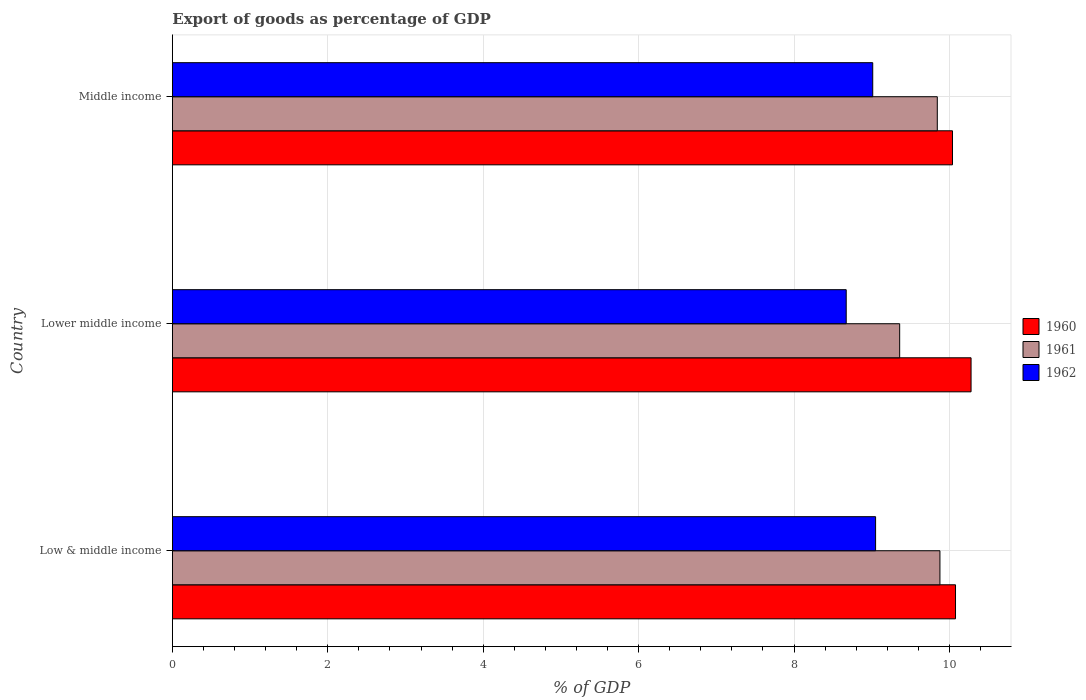How many different coloured bars are there?
Offer a very short reply. 3. How many bars are there on the 3rd tick from the bottom?
Ensure brevity in your answer.  3. What is the label of the 3rd group of bars from the top?
Provide a short and direct response. Low & middle income. In how many cases, is the number of bars for a given country not equal to the number of legend labels?
Your answer should be very brief. 0. What is the export of goods as percentage of GDP in 1960 in Lower middle income?
Your response must be concise. 10.28. Across all countries, what is the maximum export of goods as percentage of GDP in 1960?
Your response must be concise. 10.28. Across all countries, what is the minimum export of goods as percentage of GDP in 1961?
Offer a terse response. 9.36. In which country was the export of goods as percentage of GDP in 1961 maximum?
Your answer should be very brief. Low & middle income. In which country was the export of goods as percentage of GDP in 1961 minimum?
Make the answer very short. Lower middle income. What is the total export of goods as percentage of GDP in 1960 in the graph?
Your response must be concise. 30.4. What is the difference between the export of goods as percentage of GDP in 1960 in Lower middle income and that in Middle income?
Keep it short and to the point. 0.24. What is the difference between the export of goods as percentage of GDP in 1960 in Middle income and the export of goods as percentage of GDP in 1962 in Low & middle income?
Ensure brevity in your answer.  0.99. What is the average export of goods as percentage of GDP in 1961 per country?
Ensure brevity in your answer.  9.69. What is the difference between the export of goods as percentage of GDP in 1961 and export of goods as percentage of GDP in 1960 in Low & middle income?
Your answer should be very brief. -0.2. In how many countries, is the export of goods as percentage of GDP in 1960 greater than 5.2 %?
Provide a short and direct response. 3. What is the ratio of the export of goods as percentage of GDP in 1962 in Low & middle income to that in Lower middle income?
Your answer should be very brief. 1.04. Is the export of goods as percentage of GDP in 1960 in Low & middle income less than that in Middle income?
Provide a short and direct response. No. Is the difference between the export of goods as percentage of GDP in 1961 in Lower middle income and Middle income greater than the difference between the export of goods as percentage of GDP in 1960 in Lower middle income and Middle income?
Offer a very short reply. No. What is the difference between the highest and the second highest export of goods as percentage of GDP in 1961?
Provide a short and direct response. 0.03. What is the difference between the highest and the lowest export of goods as percentage of GDP in 1960?
Make the answer very short. 0.24. In how many countries, is the export of goods as percentage of GDP in 1960 greater than the average export of goods as percentage of GDP in 1960 taken over all countries?
Offer a very short reply. 1. What does the 1st bar from the bottom in Lower middle income represents?
Ensure brevity in your answer.  1960. Is it the case that in every country, the sum of the export of goods as percentage of GDP in 1962 and export of goods as percentage of GDP in 1961 is greater than the export of goods as percentage of GDP in 1960?
Provide a succinct answer. Yes. How many bars are there?
Offer a very short reply. 9. Are all the bars in the graph horizontal?
Your answer should be compact. Yes. Does the graph contain any zero values?
Offer a terse response. No. Where does the legend appear in the graph?
Your answer should be very brief. Center right. What is the title of the graph?
Ensure brevity in your answer.  Export of goods as percentage of GDP. What is the label or title of the X-axis?
Your response must be concise. % of GDP. What is the % of GDP in 1960 in Low & middle income?
Offer a very short reply. 10.08. What is the % of GDP of 1961 in Low & middle income?
Your response must be concise. 9.88. What is the % of GDP in 1962 in Low & middle income?
Offer a terse response. 9.05. What is the % of GDP of 1960 in Lower middle income?
Give a very brief answer. 10.28. What is the % of GDP of 1961 in Lower middle income?
Make the answer very short. 9.36. What is the % of GDP of 1962 in Lower middle income?
Give a very brief answer. 8.67. What is the % of GDP of 1960 in Middle income?
Keep it short and to the point. 10.04. What is the % of GDP in 1961 in Middle income?
Your answer should be very brief. 9.84. What is the % of GDP in 1962 in Middle income?
Make the answer very short. 9.01. Across all countries, what is the maximum % of GDP of 1960?
Keep it short and to the point. 10.28. Across all countries, what is the maximum % of GDP in 1961?
Offer a terse response. 9.88. Across all countries, what is the maximum % of GDP in 1962?
Your answer should be compact. 9.05. Across all countries, what is the minimum % of GDP in 1960?
Give a very brief answer. 10.04. Across all countries, what is the minimum % of GDP of 1961?
Offer a terse response. 9.36. Across all countries, what is the minimum % of GDP in 1962?
Ensure brevity in your answer.  8.67. What is the total % of GDP in 1960 in the graph?
Make the answer very short. 30.4. What is the total % of GDP of 1961 in the graph?
Offer a terse response. 29.08. What is the total % of GDP of 1962 in the graph?
Your answer should be very brief. 26.74. What is the difference between the % of GDP of 1961 in Low & middle income and that in Lower middle income?
Give a very brief answer. 0.52. What is the difference between the % of GDP of 1962 in Low & middle income and that in Lower middle income?
Provide a succinct answer. 0.38. What is the difference between the % of GDP of 1960 in Low & middle income and that in Middle income?
Provide a short and direct response. 0.04. What is the difference between the % of GDP in 1961 in Low & middle income and that in Middle income?
Offer a very short reply. 0.03. What is the difference between the % of GDP in 1962 in Low & middle income and that in Middle income?
Keep it short and to the point. 0.04. What is the difference between the % of GDP in 1960 in Lower middle income and that in Middle income?
Make the answer very short. 0.24. What is the difference between the % of GDP of 1961 in Lower middle income and that in Middle income?
Provide a short and direct response. -0.48. What is the difference between the % of GDP in 1962 in Lower middle income and that in Middle income?
Ensure brevity in your answer.  -0.34. What is the difference between the % of GDP of 1960 in Low & middle income and the % of GDP of 1961 in Lower middle income?
Offer a very short reply. 0.72. What is the difference between the % of GDP of 1960 in Low & middle income and the % of GDP of 1962 in Lower middle income?
Provide a short and direct response. 1.41. What is the difference between the % of GDP of 1961 in Low & middle income and the % of GDP of 1962 in Lower middle income?
Keep it short and to the point. 1.21. What is the difference between the % of GDP of 1960 in Low & middle income and the % of GDP of 1961 in Middle income?
Your answer should be compact. 0.23. What is the difference between the % of GDP in 1960 in Low & middle income and the % of GDP in 1962 in Middle income?
Your answer should be compact. 1.07. What is the difference between the % of GDP of 1961 in Low & middle income and the % of GDP of 1962 in Middle income?
Offer a terse response. 0.86. What is the difference between the % of GDP in 1960 in Lower middle income and the % of GDP in 1961 in Middle income?
Provide a short and direct response. 0.43. What is the difference between the % of GDP of 1960 in Lower middle income and the % of GDP of 1962 in Middle income?
Your response must be concise. 1.27. What is the difference between the % of GDP in 1961 in Lower middle income and the % of GDP in 1962 in Middle income?
Provide a succinct answer. 0.35. What is the average % of GDP in 1960 per country?
Your response must be concise. 10.13. What is the average % of GDP of 1961 per country?
Your response must be concise. 9.69. What is the average % of GDP of 1962 per country?
Make the answer very short. 8.91. What is the difference between the % of GDP of 1960 and % of GDP of 1961 in Low & middle income?
Ensure brevity in your answer.  0.2. What is the difference between the % of GDP of 1960 and % of GDP of 1962 in Low & middle income?
Keep it short and to the point. 1.03. What is the difference between the % of GDP of 1961 and % of GDP of 1962 in Low & middle income?
Provide a succinct answer. 0.83. What is the difference between the % of GDP of 1960 and % of GDP of 1961 in Lower middle income?
Provide a succinct answer. 0.92. What is the difference between the % of GDP in 1960 and % of GDP in 1962 in Lower middle income?
Give a very brief answer. 1.61. What is the difference between the % of GDP in 1961 and % of GDP in 1962 in Lower middle income?
Keep it short and to the point. 0.69. What is the difference between the % of GDP of 1960 and % of GDP of 1961 in Middle income?
Provide a succinct answer. 0.2. What is the difference between the % of GDP in 1960 and % of GDP in 1962 in Middle income?
Give a very brief answer. 1.03. What is the difference between the % of GDP in 1961 and % of GDP in 1962 in Middle income?
Your answer should be compact. 0.83. What is the ratio of the % of GDP in 1960 in Low & middle income to that in Lower middle income?
Your answer should be very brief. 0.98. What is the ratio of the % of GDP of 1961 in Low & middle income to that in Lower middle income?
Provide a succinct answer. 1.06. What is the ratio of the % of GDP of 1962 in Low & middle income to that in Lower middle income?
Ensure brevity in your answer.  1.04. What is the ratio of the % of GDP in 1961 in Low & middle income to that in Middle income?
Provide a short and direct response. 1. What is the ratio of the % of GDP of 1962 in Low & middle income to that in Middle income?
Give a very brief answer. 1. What is the ratio of the % of GDP of 1960 in Lower middle income to that in Middle income?
Your answer should be compact. 1.02. What is the ratio of the % of GDP in 1961 in Lower middle income to that in Middle income?
Provide a succinct answer. 0.95. What is the ratio of the % of GDP in 1962 in Lower middle income to that in Middle income?
Your answer should be very brief. 0.96. What is the difference between the highest and the second highest % of GDP in 1961?
Provide a short and direct response. 0.03. What is the difference between the highest and the second highest % of GDP of 1962?
Give a very brief answer. 0.04. What is the difference between the highest and the lowest % of GDP of 1960?
Make the answer very short. 0.24. What is the difference between the highest and the lowest % of GDP of 1961?
Offer a very short reply. 0.52. What is the difference between the highest and the lowest % of GDP of 1962?
Give a very brief answer. 0.38. 